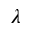<formula> <loc_0><loc_0><loc_500><loc_500>\lambda</formula> 